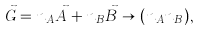Convert formula to latex. <formula><loc_0><loc_0><loc_500><loc_500>\vec { G } = n _ { A } \vec { A } + n _ { B } \vec { B } \rightarrow ( n _ { A } n _ { B } ) ,</formula> 